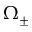Convert formula to latex. <formula><loc_0><loc_0><loc_500><loc_500>\Omega _ { \pm }</formula> 